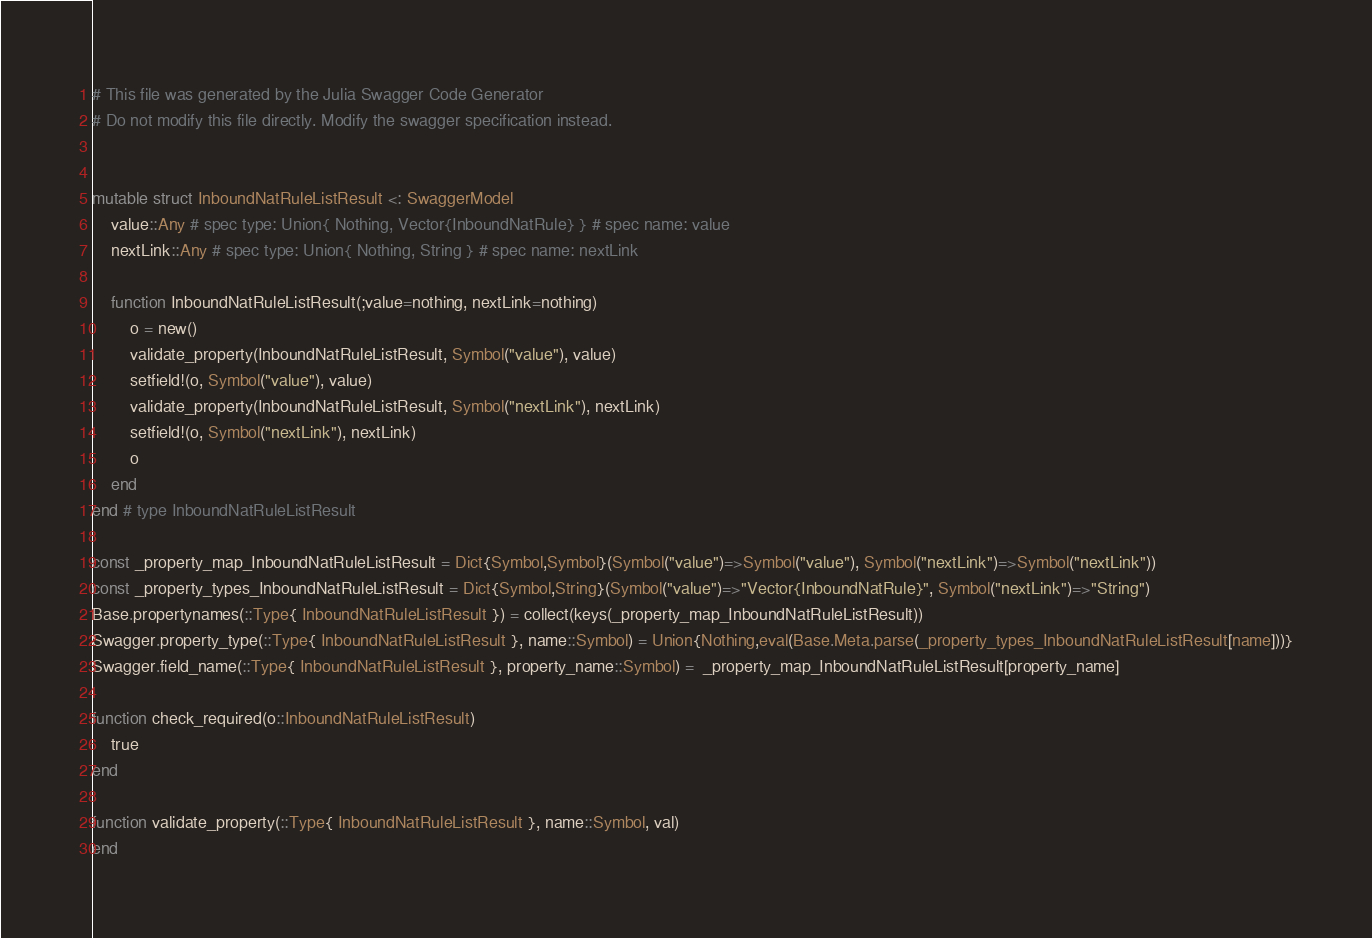Convert code to text. <code><loc_0><loc_0><loc_500><loc_500><_Julia_># This file was generated by the Julia Swagger Code Generator
# Do not modify this file directly. Modify the swagger specification instead.


mutable struct InboundNatRuleListResult <: SwaggerModel
    value::Any # spec type: Union{ Nothing, Vector{InboundNatRule} } # spec name: value
    nextLink::Any # spec type: Union{ Nothing, String } # spec name: nextLink

    function InboundNatRuleListResult(;value=nothing, nextLink=nothing)
        o = new()
        validate_property(InboundNatRuleListResult, Symbol("value"), value)
        setfield!(o, Symbol("value"), value)
        validate_property(InboundNatRuleListResult, Symbol("nextLink"), nextLink)
        setfield!(o, Symbol("nextLink"), nextLink)
        o
    end
end # type InboundNatRuleListResult

const _property_map_InboundNatRuleListResult = Dict{Symbol,Symbol}(Symbol("value")=>Symbol("value"), Symbol("nextLink")=>Symbol("nextLink"))
const _property_types_InboundNatRuleListResult = Dict{Symbol,String}(Symbol("value")=>"Vector{InboundNatRule}", Symbol("nextLink")=>"String")
Base.propertynames(::Type{ InboundNatRuleListResult }) = collect(keys(_property_map_InboundNatRuleListResult))
Swagger.property_type(::Type{ InboundNatRuleListResult }, name::Symbol) = Union{Nothing,eval(Base.Meta.parse(_property_types_InboundNatRuleListResult[name]))}
Swagger.field_name(::Type{ InboundNatRuleListResult }, property_name::Symbol) =  _property_map_InboundNatRuleListResult[property_name]

function check_required(o::InboundNatRuleListResult)
    true
end

function validate_property(::Type{ InboundNatRuleListResult }, name::Symbol, val)
end
</code> 